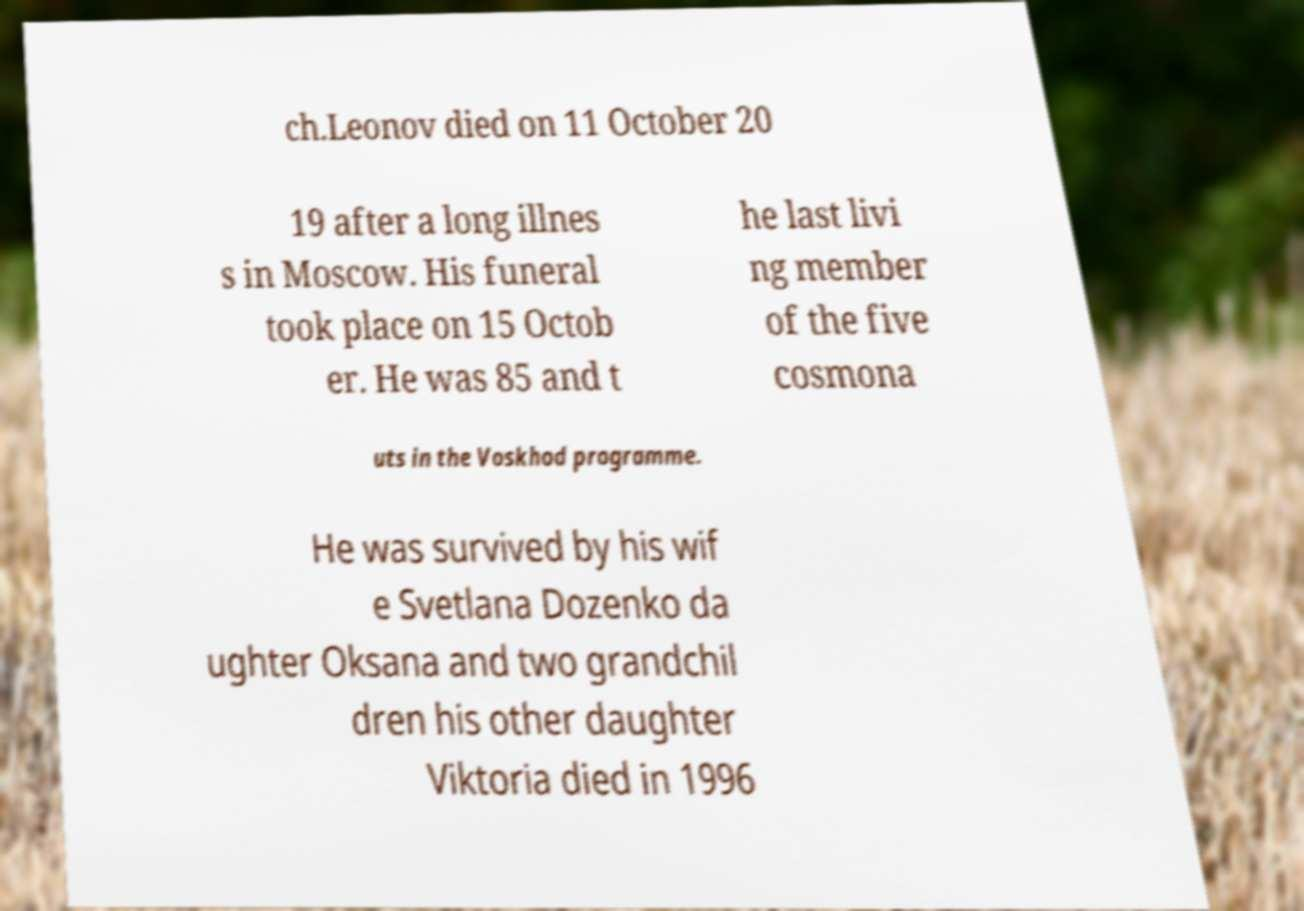Please identify and transcribe the text found in this image. ch.Leonov died on 11 October 20 19 after a long illnes s in Moscow. His funeral took place on 15 Octob er. He was 85 and t he last livi ng member of the five cosmona uts in the Voskhod programme. He was survived by his wif e Svetlana Dozenko da ughter Oksana and two grandchil dren his other daughter Viktoria died in 1996 